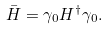Convert formula to latex. <formula><loc_0><loc_0><loc_500><loc_500>\bar { H } = \gamma _ { 0 } H ^ { \dag } \gamma _ { 0 } .</formula> 